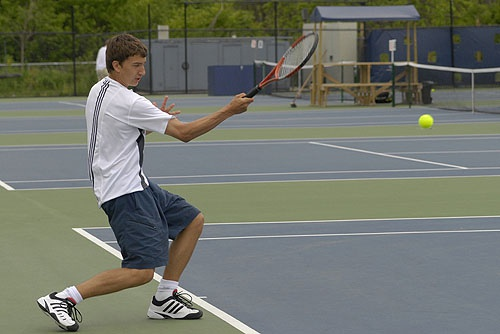Describe the objects in this image and their specific colors. I can see people in black, darkgray, lightgray, and maroon tones, tennis racket in black and gray tones, and sports ball in black, yellow, khaki, and olive tones in this image. 